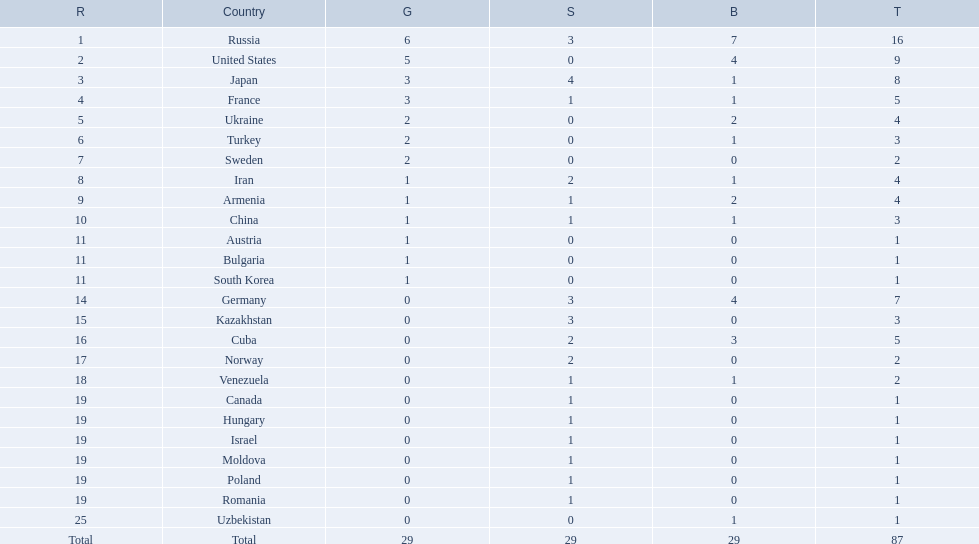Which nations are there? Russia, 6, United States, 5, Japan, 3, France, 3, Ukraine, 2, Turkey, 2, Sweden, 2, Iran, 1, Armenia, 1, China, 1, Austria, 1, Bulgaria, 1, South Korea, 1, Germany, 0, Kazakhstan, 0, Cuba, 0, Norway, 0, Venezuela, 0, Canada, 0, Hungary, 0, Israel, 0, Moldova, 0, Poland, 0, Romania, 0, Uzbekistan, 0. Which nations won gold? Russia, 6, United States, 5, Japan, 3, France, 3, Ukraine, 2, Turkey, 2, Sweden, 2, Iran, 1, Armenia, 1, China, 1, Austria, 1, Bulgaria, 1, South Korea, 1. How many golds did united states win? United States, 5. Which country has more than 5 gold medals? Russia, 6. What country is it? Russia. 